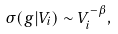Convert formula to latex. <formula><loc_0><loc_0><loc_500><loc_500>\sigma ( g | V _ { i } ) \sim V _ { i } ^ { - \beta } ,</formula> 